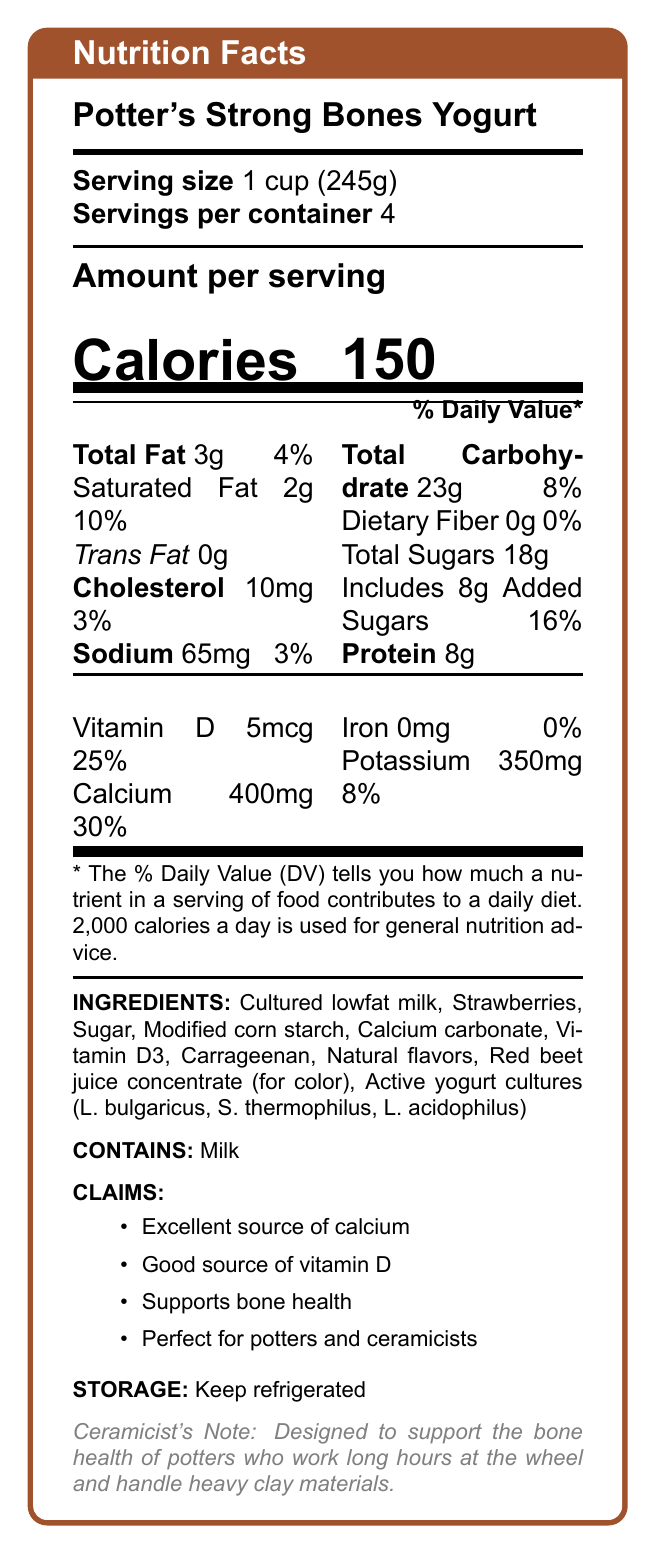What is the serving size of Potter's Strong Bones Yogurt? The document states that the serving size is 1 cup (245g).
Answer: 1 cup (245g) How many servings are there per container? The document specifies that there are 4 servings per container.
Answer: 4 How many calories are in one serving? According to the document, each serving contains 150 calories.
Answer: 150 calories What percentage of the daily value of calcium does one serving provide? The document indicates that one serving provides 30% of the daily value of calcium.
Answer: 30% What is the protein content per serving? The document states that each serving contains 8g of protein.
Answer: 8g What ingredients are in this yogurt? The document lists all these as the ingredients in the yogurt.
Answer: Cultured lowfat milk, Strawberries, Sugar, Modified corn starch, Calcium carbonate, Vitamin D3, Carrageenan, Natural flavors, Red beet juice concentrate (for color), Active yogurt cultures (L. bulgaricus, S. thermophilus, L. acidophilus) What nutrient has a 0% daily value per serving? A. Iron B. Fiber C. Trans Fat D. Vitamin D The document shows that Iron has a 0% daily value per serving.
Answer: A. Iron Which nutrient contributes the highest % daily value per serving? A. Potassium B. Protein C. Vitamin D D. Calcium The document indicates that calcium provides 30% of the daily value per serving, which is the highest percentage among listed nutrients.
Answer: D. Calcium Does the yogurt contain any fiber? The document states that the dietary fiber content is 0g per serving.
Answer: No Is this yogurt recommended for individuals with milk allergies? The document lists "Milk" under the "Contains" section indicating the presence of milk, making it unsuitable for those with milk allergies.
Answer: No Summarize the main ideas presented in the document. The main ideas focus on the nutritional benefits of the yogurt, particularly its role in supporting bone health for potters, detailed nutritional content per serving, and ingredients.
Answer: The document provides the nutrition facts for Potter's Strong Bones Yogurt, highlighting its calcium and vitamin D content to support bone health, especially for potters and ceramicists. It includes details on serving size, calories, nutrient amounts, and ingredients. It also lists claims about its health benefits, storage instructions, and a note on its specific benefits for ceramicists. What is the relationship between added sugars and total sugars? The document specifies that there are 18g of total sugars, and within that, 8g are identified as added sugars.
Answer: 8g of the total 18g of sugars are added sugars. What kind of cultures are present in the yogurt? The document includes these active yogurt cultures in the ingredients list.
Answer: L. bulgaricus, S. thermophilus, L. acidophilus Why is this yogurt particularly beneficial for potters? The ceramicist's note explains that the yogurt is designed to support bone health for potters due to the physical demands of their work.
Answer: It supports bone health, which is crucial for potters who work long hours at the wheel and handle heavy clay materials. What is the amount of cholesterol per serving? According to the document, each serving contains 10mg of cholesterol.
Answer: 10mg What color is associated with the yogurt in the document design? The document uses 'claybrown' for the color scheme to match the theme of pottery. This can be inferred from the color definitions in the LaTeX code.
Answer: Clay brown Is there enough information to determine the specific brand or company producing Potter's Strong Bones Yogurt? The document provides nutritional details and health claims but does not specify the brand or company producing the yogurt.
Answer: Not enough information 